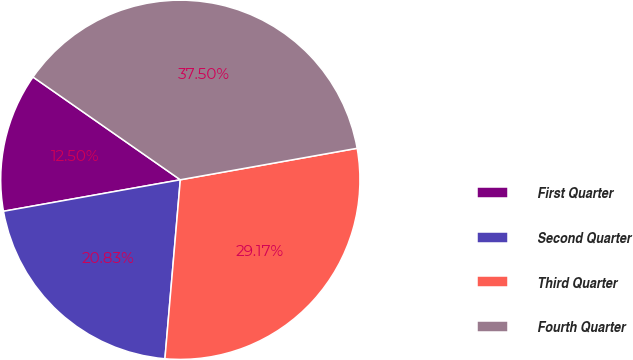Convert chart. <chart><loc_0><loc_0><loc_500><loc_500><pie_chart><fcel>First Quarter<fcel>Second Quarter<fcel>Third Quarter<fcel>Fourth Quarter<nl><fcel>12.5%<fcel>20.83%<fcel>29.17%<fcel>37.5%<nl></chart> 